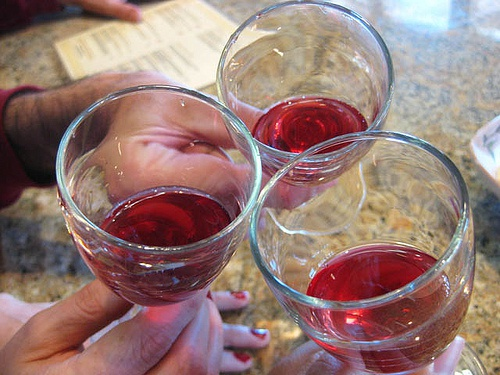Describe the objects in this image and their specific colors. I can see wine glass in black, darkgray, tan, brown, and maroon tones, dining table in black, darkgray, tan, and gray tones, wine glass in black, maroon, brown, lightpink, and gray tones, people in black, brown, and gray tones, and people in black, brown, and maroon tones in this image. 